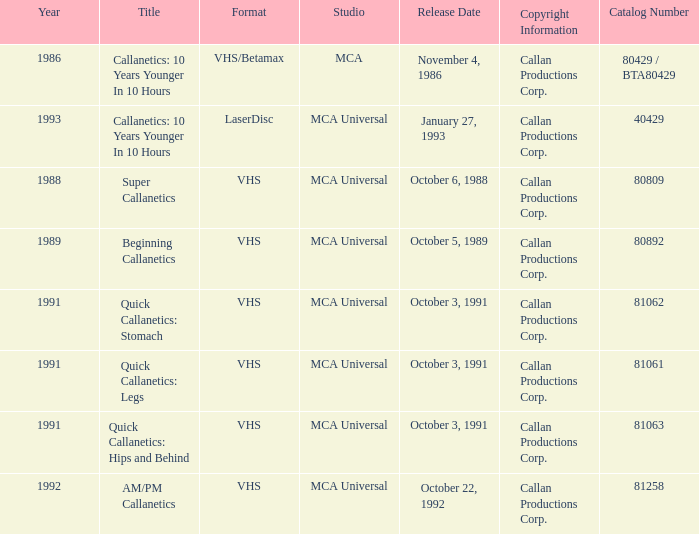Name the catalog number for am/pm callanetics 81258.0. 